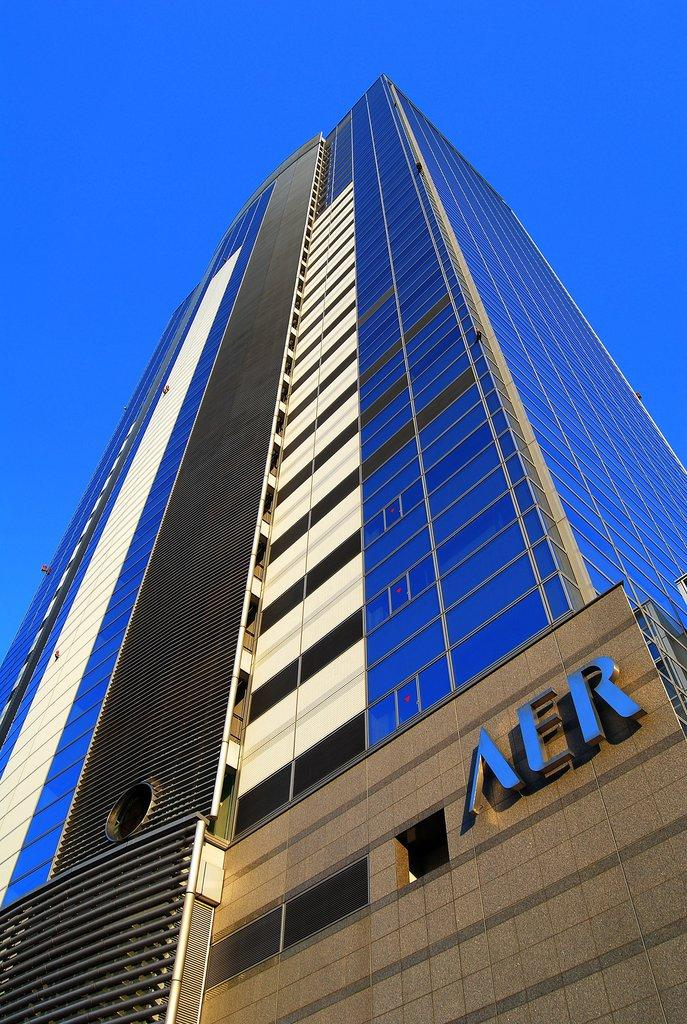What type of structure is visible in the image? There is a building in the image. What can be seen attached to the wall on the right side? There are letter blocks attached to the wall on the right side. What is visible at the top of the image? The sky is visible at the top of the image. What color is the sky in the image? The color of the sky is blue. How much profit does the nail on the wall generate in the image? There is no nail present in the image, and therefore no profit can be generated. 